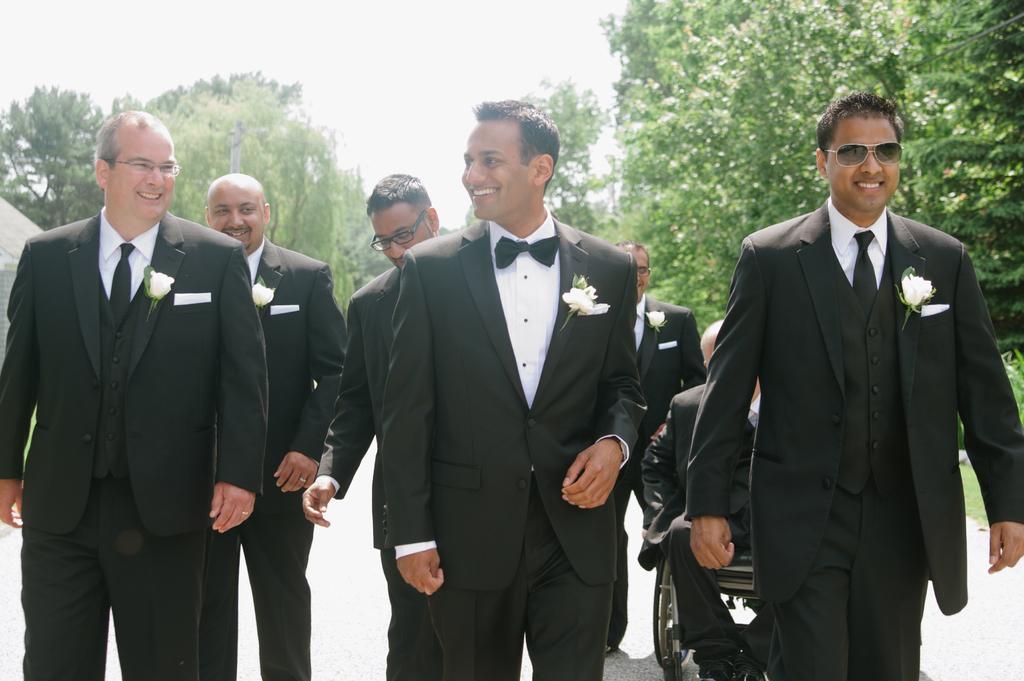Could you give a brief overview of what you see in this image? This picture describe about six man wearing black color coat with bow tie and white flower on the coat, smiling and walking on the road. In the background we can see some trees. 